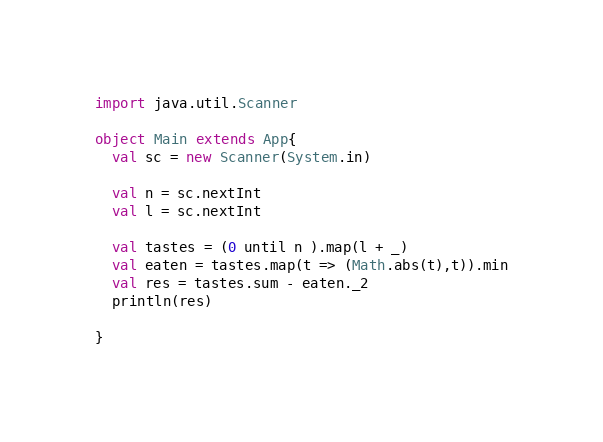Convert code to text. <code><loc_0><loc_0><loc_500><loc_500><_Scala_>import java.util.Scanner

object Main extends App{
  val sc = new Scanner(System.in)

  val n = sc.nextInt
  val l = sc.nextInt

  val tastes = (0 until n ).map(l + _)
  val eaten = tastes.map(t => (Math.abs(t),t)).min
  val res = tastes.sum - eaten._2
  println(res)

}
</code> 